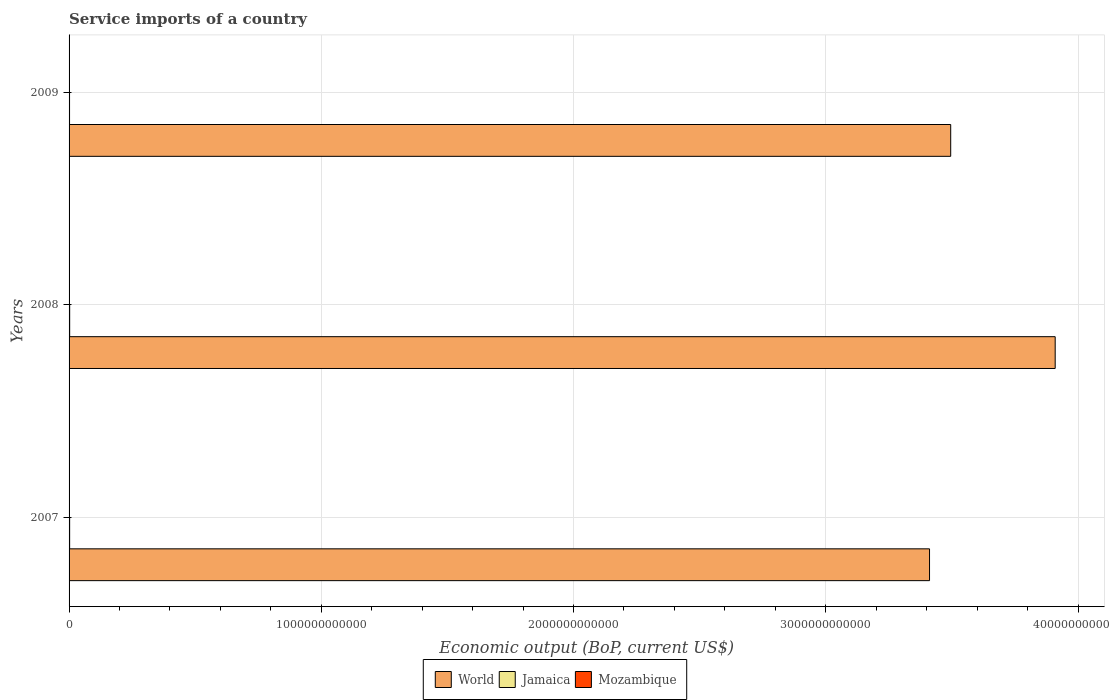How many different coloured bars are there?
Your answer should be compact. 3. Are the number of bars per tick equal to the number of legend labels?
Ensure brevity in your answer.  Yes. Are the number of bars on each tick of the Y-axis equal?
Your answer should be very brief. Yes. How many bars are there on the 3rd tick from the bottom?
Make the answer very short. 3. What is the service imports in Mozambique in 2008?
Your answer should be very brief. 8.83e+08. Across all years, what is the maximum service imports in Mozambique?
Provide a succinct answer. 1.04e+09. Across all years, what is the minimum service imports in Jamaica?
Your response must be concise. 1.88e+09. What is the total service imports in World in the graph?
Ensure brevity in your answer.  1.08e+13. What is the difference between the service imports in Mozambique in 2008 and that in 2009?
Give a very brief answer. -1.61e+08. What is the difference between the service imports in Jamaica in 2009 and the service imports in World in 2007?
Give a very brief answer. -3.41e+12. What is the average service imports in World per year?
Give a very brief answer. 3.61e+12. In the year 2009, what is the difference between the service imports in Mozambique and service imports in Jamaica?
Give a very brief answer. -8.36e+08. What is the ratio of the service imports in Jamaica in 2007 to that in 2008?
Your answer should be very brief. 0.96. Is the service imports in Mozambique in 2007 less than that in 2008?
Make the answer very short. Yes. Is the difference between the service imports in Mozambique in 2008 and 2009 greater than the difference between the service imports in Jamaica in 2008 and 2009?
Your answer should be very brief. No. What is the difference between the highest and the second highest service imports in Mozambique?
Ensure brevity in your answer.  1.61e+08. What is the difference between the highest and the lowest service imports in Mozambique?
Ensure brevity in your answer.  1.88e+08. What does the 2nd bar from the bottom in 2007 represents?
Ensure brevity in your answer.  Jamaica. Is it the case that in every year, the sum of the service imports in World and service imports in Mozambique is greater than the service imports in Jamaica?
Give a very brief answer. Yes. Are all the bars in the graph horizontal?
Provide a short and direct response. Yes. How many years are there in the graph?
Keep it short and to the point. 3. What is the difference between two consecutive major ticks on the X-axis?
Provide a short and direct response. 1.00e+12. Are the values on the major ticks of X-axis written in scientific E-notation?
Offer a very short reply. No. Does the graph contain grids?
Offer a very short reply. Yes. How many legend labels are there?
Give a very brief answer. 3. What is the title of the graph?
Your answer should be very brief. Service imports of a country. What is the label or title of the X-axis?
Provide a short and direct response. Economic output (BoP, current US$). What is the Economic output (BoP, current US$) of World in 2007?
Offer a terse response. 3.41e+12. What is the Economic output (BoP, current US$) in Jamaica in 2007?
Ensure brevity in your answer.  2.28e+09. What is the Economic output (BoP, current US$) in Mozambique in 2007?
Provide a succinct answer. 8.57e+08. What is the Economic output (BoP, current US$) in World in 2008?
Offer a very short reply. 3.91e+12. What is the Economic output (BoP, current US$) in Jamaica in 2008?
Ensure brevity in your answer.  2.37e+09. What is the Economic output (BoP, current US$) of Mozambique in 2008?
Give a very brief answer. 8.83e+08. What is the Economic output (BoP, current US$) in World in 2009?
Offer a terse response. 3.50e+12. What is the Economic output (BoP, current US$) in Jamaica in 2009?
Offer a very short reply. 1.88e+09. What is the Economic output (BoP, current US$) in Mozambique in 2009?
Your answer should be compact. 1.04e+09. Across all years, what is the maximum Economic output (BoP, current US$) in World?
Your answer should be very brief. 3.91e+12. Across all years, what is the maximum Economic output (BoP, current US$) in Jamaica?
Ensure brevity in your answer.  2.37e+09. Across all years, what is the maximum Economic output (BoP, current US$) in Mozambique?
Make the answer very short. 1.04e+09. Across all years, what is the minimum Economic output (BoP, current US$) of World?
Make the answer very short. 3.41e+12. Across all years, what is the minimum Economic output (BoP, current US$) of Jamaica?
Offer a terse response. 1.88e+09. Across all years, what is the minimum Economic output (BoP, current US$) in Mozambique?
Your answer should be very brief. 8.57e+08. What is the total Economic output (BoP, current US$) in World in the graph?
Your answer should be compact. 1.08e+13. What is the total Economic output (BoP, current US$) of Jamaica in the graph?
Ensure brevity in your answer.  6.53e+09. What is the total Economic output (BoP, current US$) in Mozambique in the graph?
Your answer should be very brief. 2.78e+09. What is the difference between the Economic output (BoP, current US$) in World in 2007 and that in 2008?
Your answer should be very brief. -4.98e+11. What is the difference between the Economic output (BoP, current US$) in Jamaica in 2007 and that in 2008?
Provide a succinct answer. -8.54e+07. What is the difference between the Economic output (BoP, current US$) of Mozambique in 2007 and that in 2008?
Your answer should be compact. -2.68e+07. What is the difference between the Economic output (BoP, current US$) in World in 2007 and that in 2009?
Provide a short and direct response. -8.39e+1. What is the difference between the Economic output (BoP, current US$) of Jamaica in 2007 and that in 2009?
Offer a very short reply. 4.01e+08. What is the difference between the Economic output (BoP, current US$) of Mozambique in 2007 and that in 2009?
Offer a very short reply. -1.88e+08. What is the difference between the Economic output (BoP, current US$) of World in 2008 and that in 2009?
Make the answer very short. 4.14e+11. What is the difference between the Economic output (BoP, current US$) in Jamaica in 2008 and that in 2009?
Keep it short and to the point. 4.86e+08. What is the difference between the Economic output (BoP, current US$) of Mozambique in 2008 and that in 2009?
Make the answer very short. -1.61e+08. What is the difference between the Economic output (BoP, current US$) of World in 2007 and the Economic output (BoP, current US$) of Jamaica in 2008?
Offer a terse response. 3.41e+12. What is the difference between the Economic output (BoP, current US$) of World in 2007 and the Economic output (BoP, current US$) of Mozambique in 2008?
Provide a short and direct response. 3.41e+12. What is the difference between the Economic output (BoP, current US$) of Jamaica in 2007 and the Economic output (BoP, current US$) of Mozambique in 2008?
Your answer should be compact. 1.40e+09. What is the difference between the Economic output (BoP, current US$) in World in 2007 and the Economic output (BoP, current US$) in Jamaica in 2009?
Provide a short and direct response. 3.41e+12. What is the difference between the Economic output (BoP, current US$) of World in 2007 and the Economic output (BoP, current US$) of Mozambique in 2009?
Provide a short and direct response. 3.41e+12. What is the difference between the Economic output (BoP, current US$) in Jamaica in 2007 and the Economic output (BoP, current US$) in Mozambique in 2009?
Offer a very short reply. 1.24e+09. What is the difference between the Economic output (BoP, current US$) of World in 2008 and the Economic output (BoP, current US$) of Jamaica in 2009?
Keep it short and to the point. 3.91e+12. What is the difference between the Economic output (BoP, current US$) of World in 2008 and the Economic output (BoP, current US$) of Mozambique in 2009?
Your answer should be compact. 3.91e+12. What is the difference between the Economic output (BoP, current US$) in Jamaica in 2008 and the Economic output (BoP, current US$) in Mozambique in 2009?
Offer a very short reply. 1.32e+09. What is the average Economic output (BoP, current US$) of World per year?
Your answer should be compact. 3.61e+12. What is the average Economic output (BoP, current US$) of Jamaica per year?
Provide a short and direct response. 2.18e+09. What is the average Economic output (BoP, current US$) of Mozambique per year?
Your answer should be very brief. 9.28e+08. In the year 2007, what is the difference between the Economic output (BoP, current US$) of World and Economic output (BoP, current US$) of Jamaica?
Your answer should be very brief. 3.41e+12. In the year 2007, what is the difference between the Economic output (BoP, current US$) in World and Economic output (BoP, current US$) in Mozambique?
Your answer should be compact. 3.41e+12. In the year 2007, what is the difference between the Economic output (BoP, current US$) of Jamaica and Economic output (BoP, current US$) of Mozambique?
Offer a terse response. 1.43e+09. In the year 2008, what is the difference between the Economic output (BoP, current US$) of World and Economic output (BoP, current US$) of Jamaica?
Your answer should be very brief. 3.91e+12. In the year 2008, what is the difference between the Economic output (BoP, current US$) of World and Economic output (BoP, current US$) of Mozambique?
Provide a short and direct response. 3.91e+12. In the year 2008, what is the difference between the Economic output (BoP, current US$) of Jamaica and Economic output (BoP, current US$) of Mozambique?
Make the answer very short. 1.48e+09. In the year 2009, what is the difference between the Economic output (BoP, current US$) of World and Economic output (BoP, current US$) of Jamaica?
Ensure brevity in your answer.  3.49e+12. In the year 2009, what is the difference between the Economic output (BoP, current US$) in World and Economic output (BoP, current US$) in Mozambique?
Keep it short and to the point. 3.49e+12. In the year 2009, what is the difference between the Economic output (BoP, current US$) in Jamaica and Economic output (BoP, current US$) in Mozambique?
Offer a very short reply. 8.36e+08. What is the ratio of the Economic output (BoP, current US$) in World in 2007 to that in 2008?
Your answer should be compact. 0.87. What is the ratio of the Economic output (BoP, current US$) in Jamaica in 2007 to that in 2008?
Your answer should be very brief. 0.96. What is the ratio of the Economic output (BoP, current US$) in Mozambique in 2007 to that in 2008?
Offer a terse response. 0.97. What is the ratio of the Economic output (BoP, current US$) of World in 2007 to that in 2009?
Make the answer very short. 0.98. What is the ratio of the Economic output (BoP, current US$) in Jamaica in 2007 to that in 2009?
Keep it short and to the point. 1.21. What is the ratio of the Economic output (BoP, current US$) of Mozambique in 2007 to that in 2009?
Give a very brief answer. 0.82. What is the ratio of the Economic output (BoP, current US$) of World in 2008 to that in 2009?
Provide a short and direct response. 1.12. What is the ratio of the Economic output (BoP, current US$) of Jamaica in 2008 to that in 2009?
Your answer should be very brief. 1.26. What is the ratio of the Economic output (BoP, current US$) of Mozambique in 2008 to that in 2009?
Provide a succinct answer. 0.85. What is the difference between the highest and the second highest Economic output (BoP, current US$) of World?
Offer a terse response. 4.14e+11. What is the difference between the highest and the second highest Economic output (BoP, current US$) of Jamaica?
Keep it short and to the point. 8.54e+07. What is the difference between the highest and the second highest Economic output (BoP, current US$) of Mozambique?
Offer a terse response. 1.61e+08. What is the difference between the highest and the lowest Economic output (BoP, current US$) of World?
Provide a succinct answer. 4.98e+11. What is the difference between the highest and the lowest Economic output (BoP, current US$) in Jamaica?
Provide a succinct answer. 4.86e+08. What is the difference between the highest and the lowest Economic output (BoP, current US$) in Mozambique?
Offer a very short reply. 1.88e+08. 